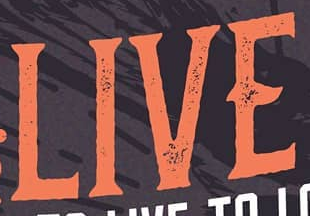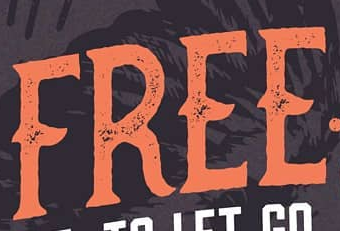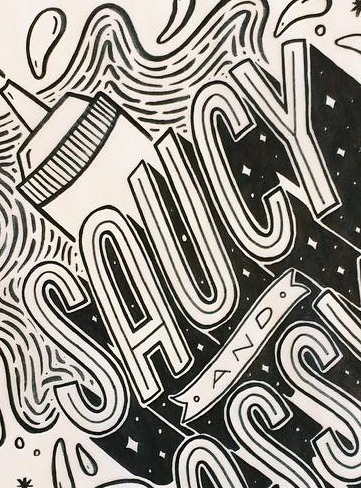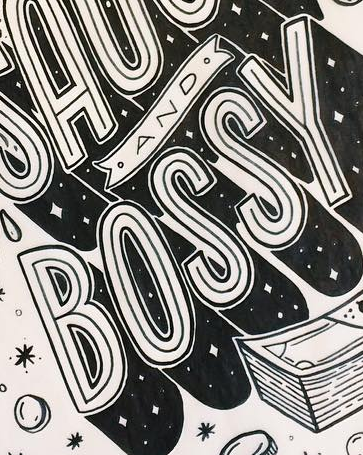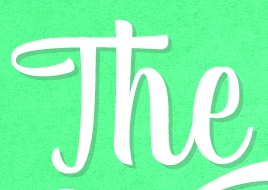What text is displayed in these images sequentially, separated by a semicolon? LIVE; FREE; SAUCY; BOSSY; The 